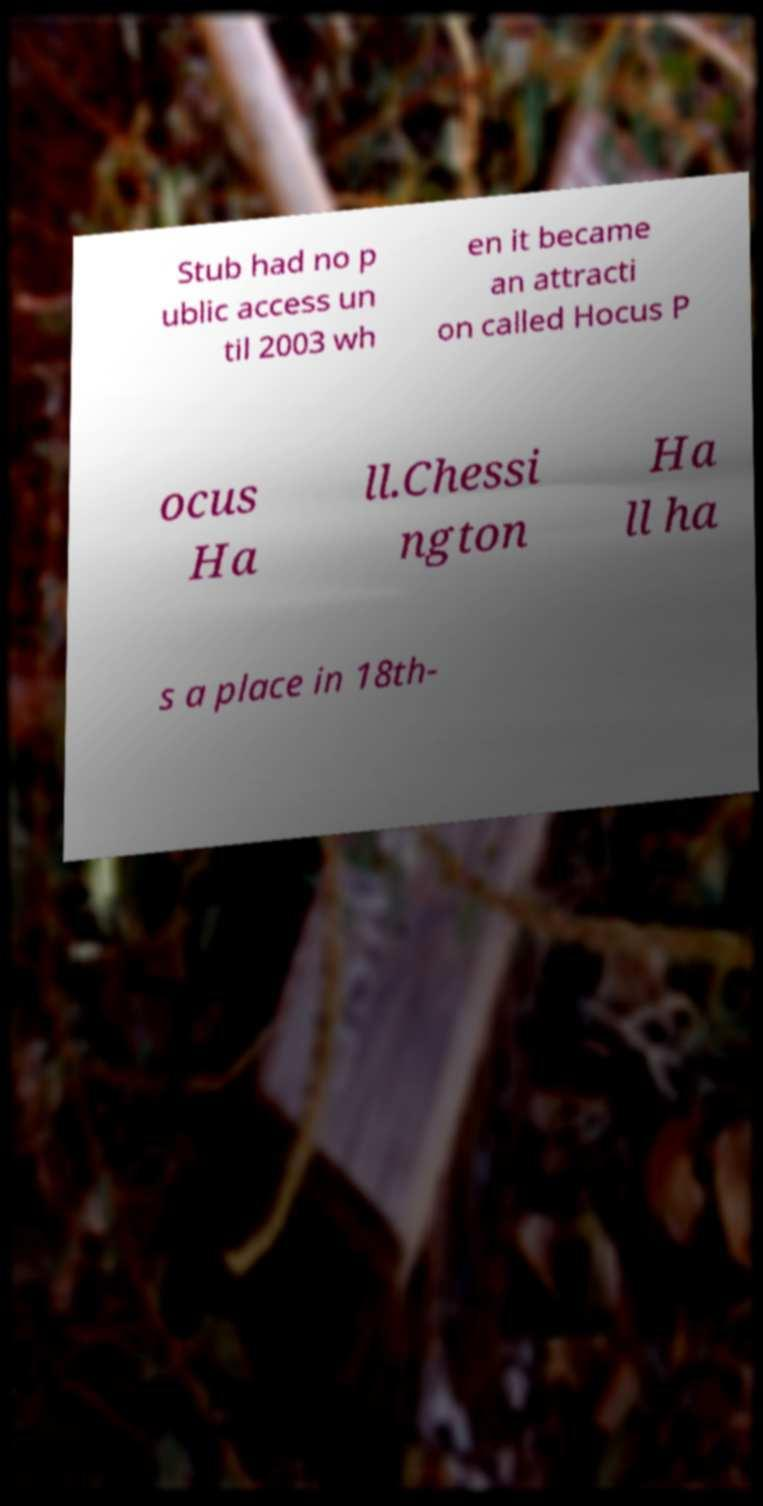Can you read and provide the text displayed in the image?This photo seems to have some interesting text. Can you extract and type it out for me? Stub had no p ublic access un til 2003 wh en it became an attracti on called Hocus P ocus Ha ll.Chessi ngton Ha ll ha s a place in 18th- 